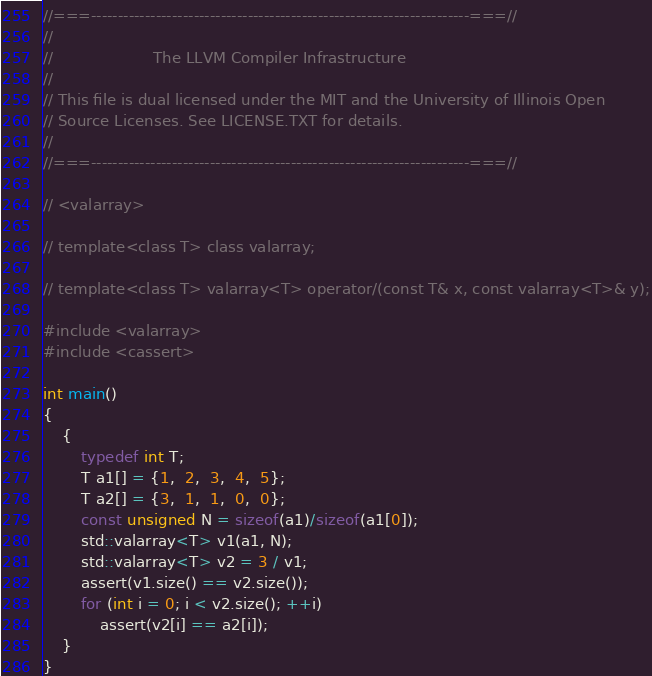Convert code to text. <code><loc_0><loc_0><loc_500><loc_500><_C++_>//===----------------------------------------------------------------------===//
//
//                     The LLVM Compiler Infrastructure
//
// This file is dual licensed under the MIT and the University of Illinois Open
// Source Licenses. See LICENSE.TXT for details.
//
//===----------------------------------------------------------------------===//

// <valarray>

// template<class T> class valarray;

// template<class T> valarray<T> operator/(const T& x, const valarray<T>& y);

#include <valarray>
#include <cassert>

int main()
{
    {
        typedef int T;
        T a1[] = {1,  2,  3,  4,  5};
        T a2[] = {3,  1,  1,  0,  0};
        const unsigned N = sizeof(a1)/sizeof(a1[0]);
        std::valarray<T> v1(a1, N);
        std::valarray<T> v2 = 3 / v1;
        assert(v1.size() == v2.size());
        for (int i = 0; i < v2.size(); ++i)
            assert(v2[i] == a2[i]);
    }
}
</code> 